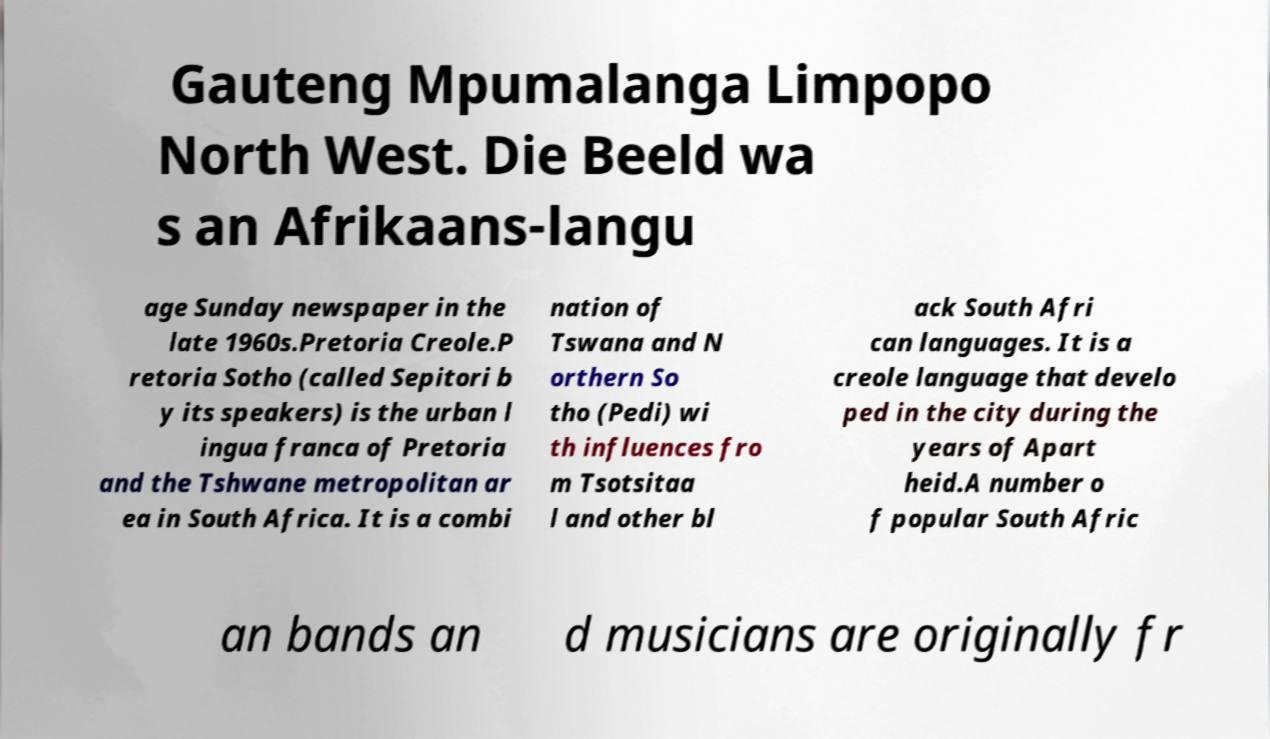Please identify and transcribe the text found in this image. Gauteng Mpumalanga Limpopo North West. Die Beeld wa s an Afrikaans-langu age Sunday newspaper in the late 1960s.Pretoria Creole.P retoria Sotho (called Sepitori b y its speakers) is the urban l ingua franca of Pretoria and the Tshwane metropolitan ar ea in South Africa. It is a combi nation of Tswana and N orthern So tho (Pedi) wi th influences fro m Tsotsitaa l and other bl ack South Afri can languages. It is a creole language that develo ped in the city during the years of Apart heid.A number o f popular South Afric an bands an d musicians are originally fr 